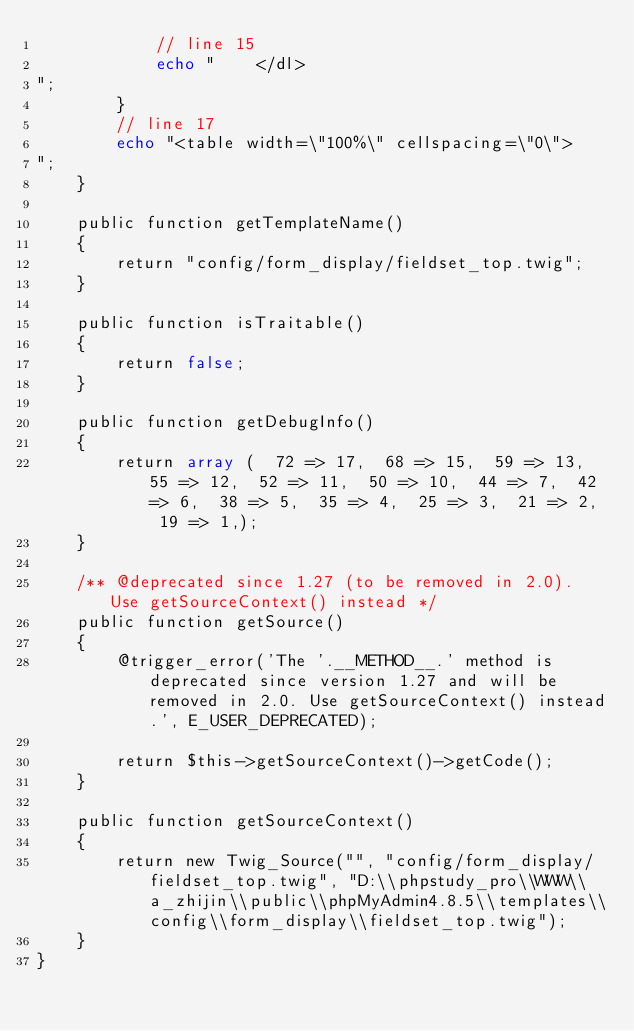Convert code to text. <code><loc_0><loc_0><loc_500><loc_500><_PHP_>            // line 15
            echo "    </dl>
";
        }
        // line 17
        echo "<table width=\"100%\" cellspacing=\"0\">
";
    }

    public function getTemplateName()
    {
        return "config/form_display/fieldset_top.twig";
    }

    public function isTraitable()
    {
        return false;
    }

    public function getDebugInfo()
    {
        return array (  72 => 17,  68 => 15,  59 => 13,  55 => 12,  52 => 11,  50 => 10,  44 => 7,  42 => 6,  38 => 5,  35 => 4,  25 => 3,  21 => 2,  19 => 1,);
    }

    /** @deprecated since 1.27 (to be removed in 2.0). Use getSourceContext() instead */
    public function getSource()
    {
        @trigger_error('The '.__METHOD__.' method is deprecated since version 1.27 and will be removed in 2.0. Use getSourceContext() instead.', E_USER_DEPRECATED);

        return $this->getSourceContext()->getCode();
    }

    public function getSourceContext()
    {
        return new Twig_Source("", "config/form_display/fieldset_top.twig", "D:\\phpstudy_pro\\WWW\\a_zhijin\\public\\phpMyAdmin4.8.5\\templates\\config\\form_display\\fieldset_top.twig");
    }
}
</code> 